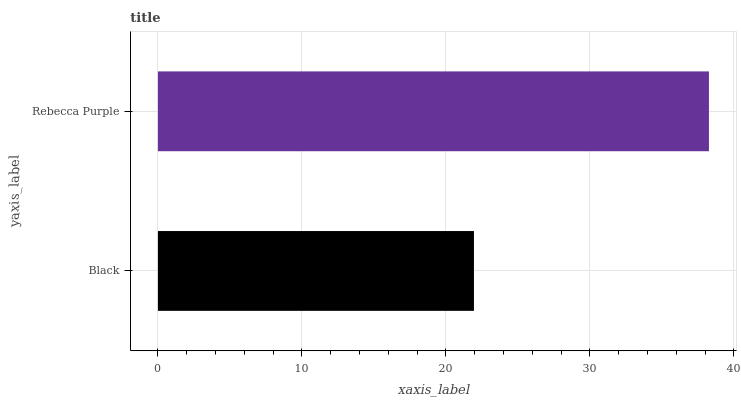Is Black the minimum?
Answer yes or no. Yes. Is Rebecca Purple the maximum?
Answer yes or no. Yes. Is Rebecca Purple the minimum?
Answer yes or no. No. Is Rebecca Purple greater than Black?
Answer yes or no. Yes. Is Black less than Rebecca Purple?
Answer yes or no. Yes. Is Black greater than Rebecca Purple?
Answer yes or no. No. Is Rebecca Purple less than Black?
Answer yes or no. No. Is Rebecca Purple the high median?
Answer yes or no. Yes. Is Black the low median?
Answer yes or no. Yes. Is Black the high median?
Answer yes or no. No. Is Rebecca Purple the low median?
Answer yes or no. No. 